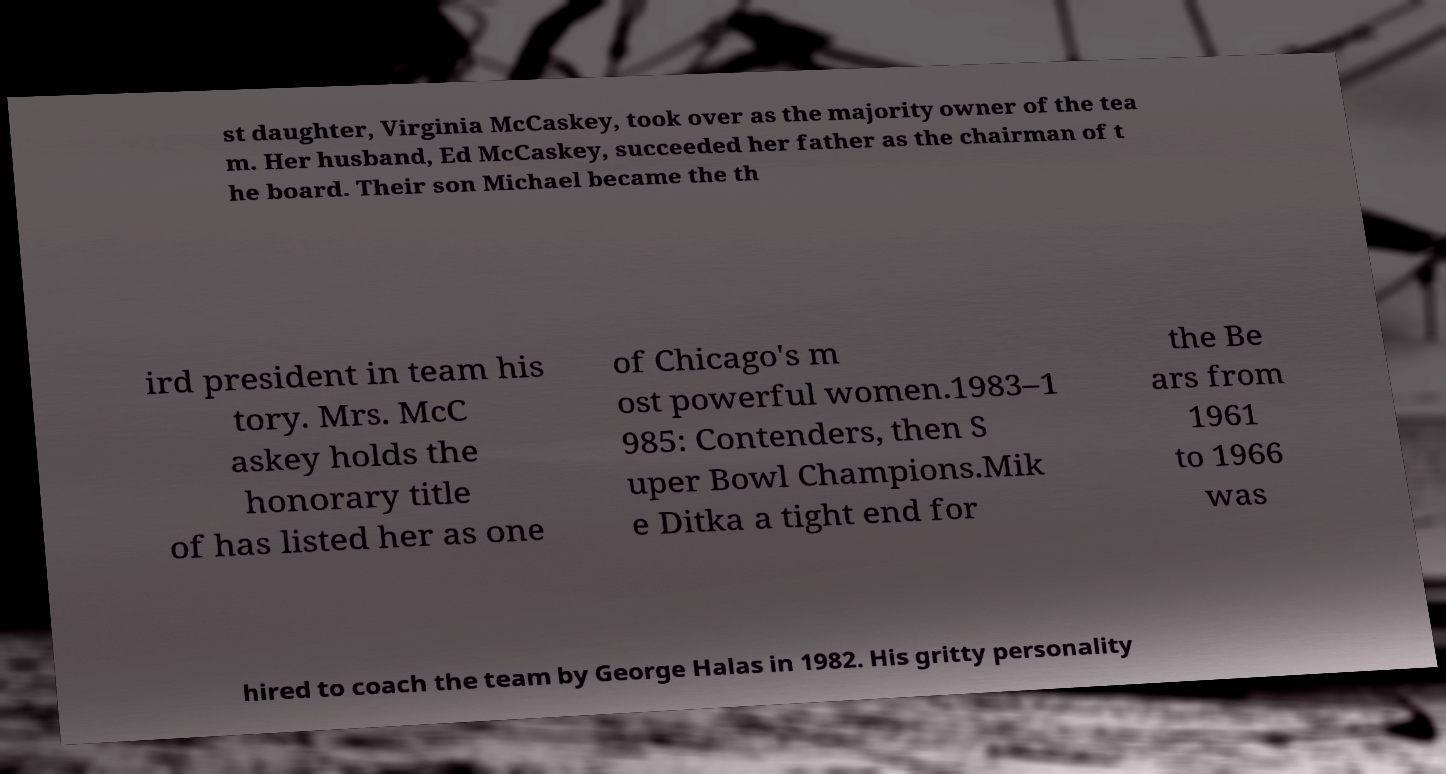Could you assist in decoding the text presented in this image and type it out clearly? st daughter, Virginia McCaskey, took over as the majority owner of the tea m. Her husband, Ed McCaskey, succeeded her father as the chairman of t he board. Their son Michael became the th ird president in team his tory. Mrs. McC askey holds the honorary title of has listed her as one of Chicago's m ost powerful women.1983–1 985: Contenders, then S uper Bowl Champions.Mik e Ditka a tight end for the Be ars from 1961 to 1966 was hired to coach the team by George Halas in 1982. His gritty personality 